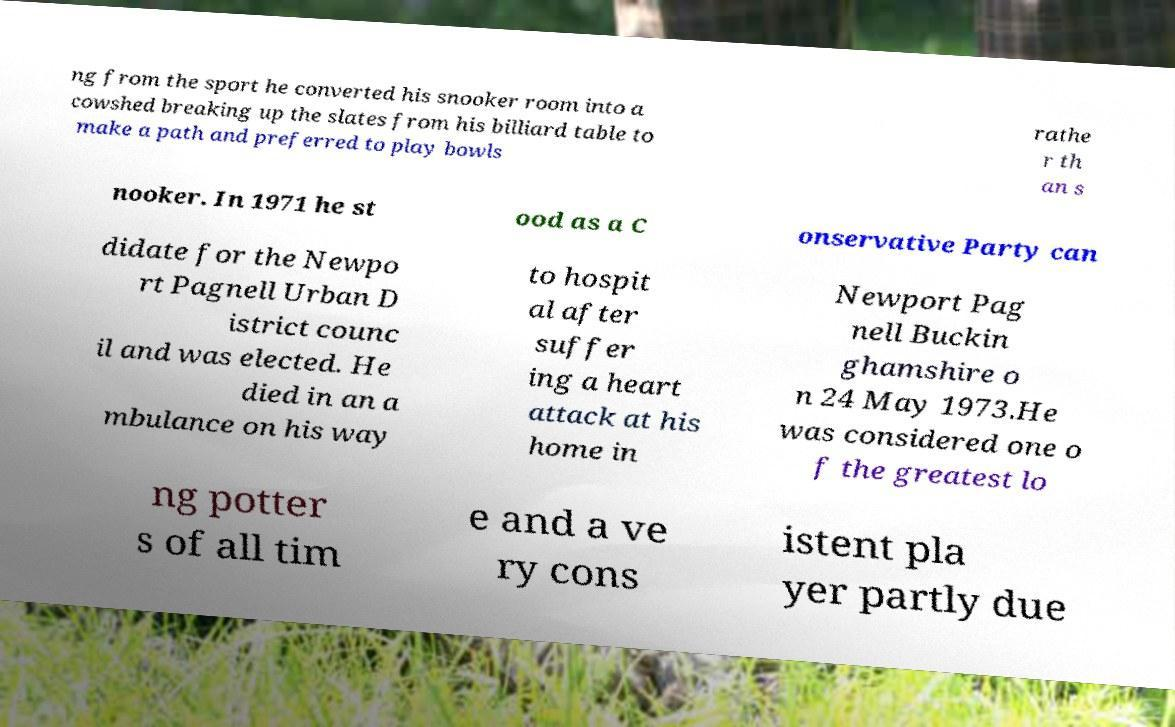Could you assist in decoding the text presented in this image and type it out clearly? ng from the sport he converted his snooker room into a cowshed breaking up the slates from his billiard table to make a path and preferred to play bowls rathe r th an s nooker. In 1971 he st ood as a C onservative Party can didate for the Newpo rt Pagnell Urban D istrict counc il and was elected. He died in an a mbulance on his way to hospit al after suffer ing a heart attack at his home in Newport Pag nell Buckin ghamshire o n 24 May 1973.He was considered one o f the greatest lo ng potter s of all tim e and a ve ry cons istent pla yer partly due 